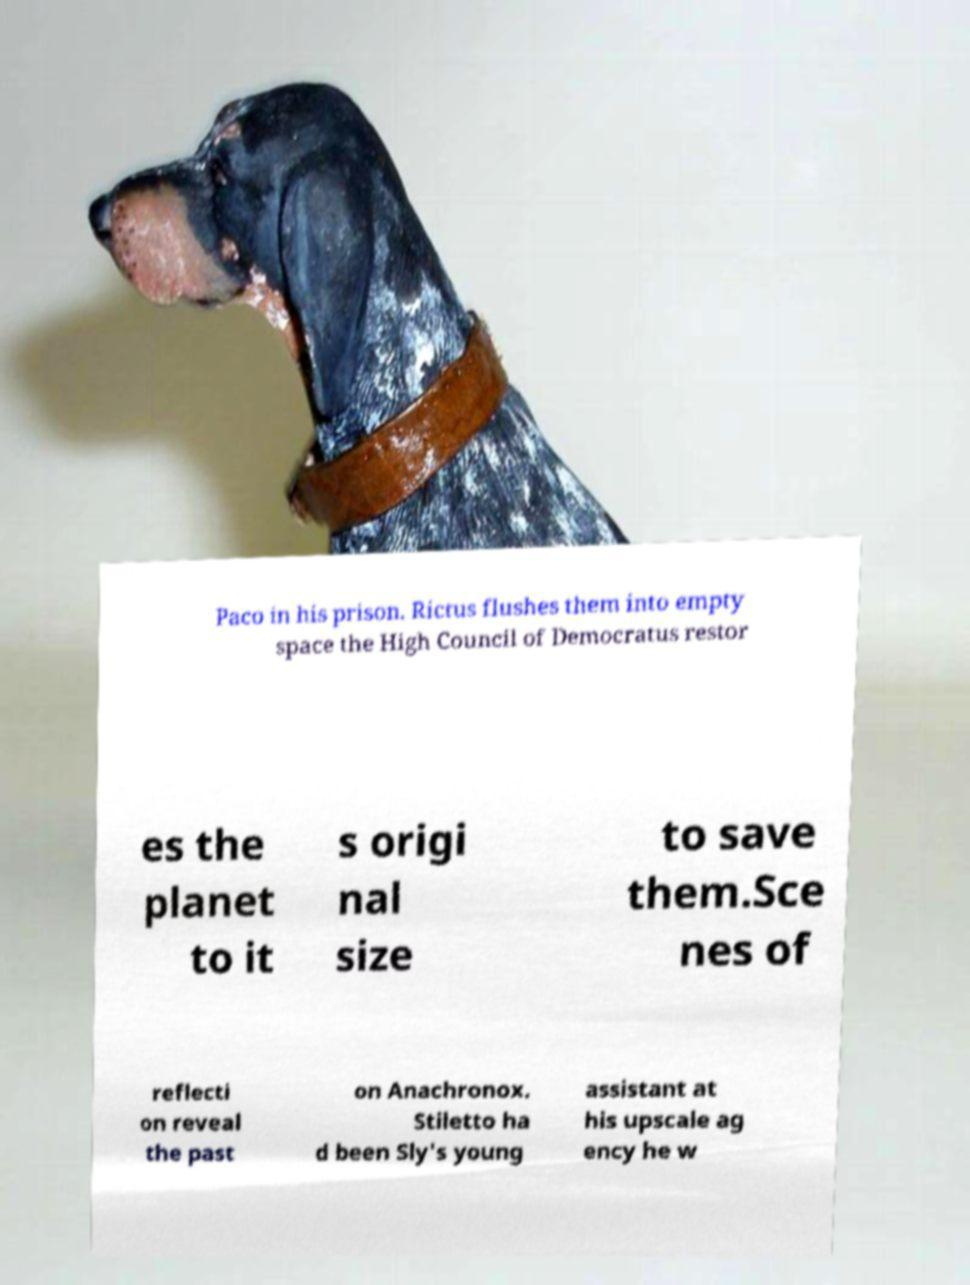There's text embedded in this image that I need extracted. Can you transcribe it verbatim? Paco in his prison. Rictus flushes them into empty space the High Council of Democratus restor es the planet to it s origi nal size to save them.Sce nes of reflecti on reveal the past on Anachronox. Stiletto ha d been Sly's young assistant at his upscale ag ency he w 